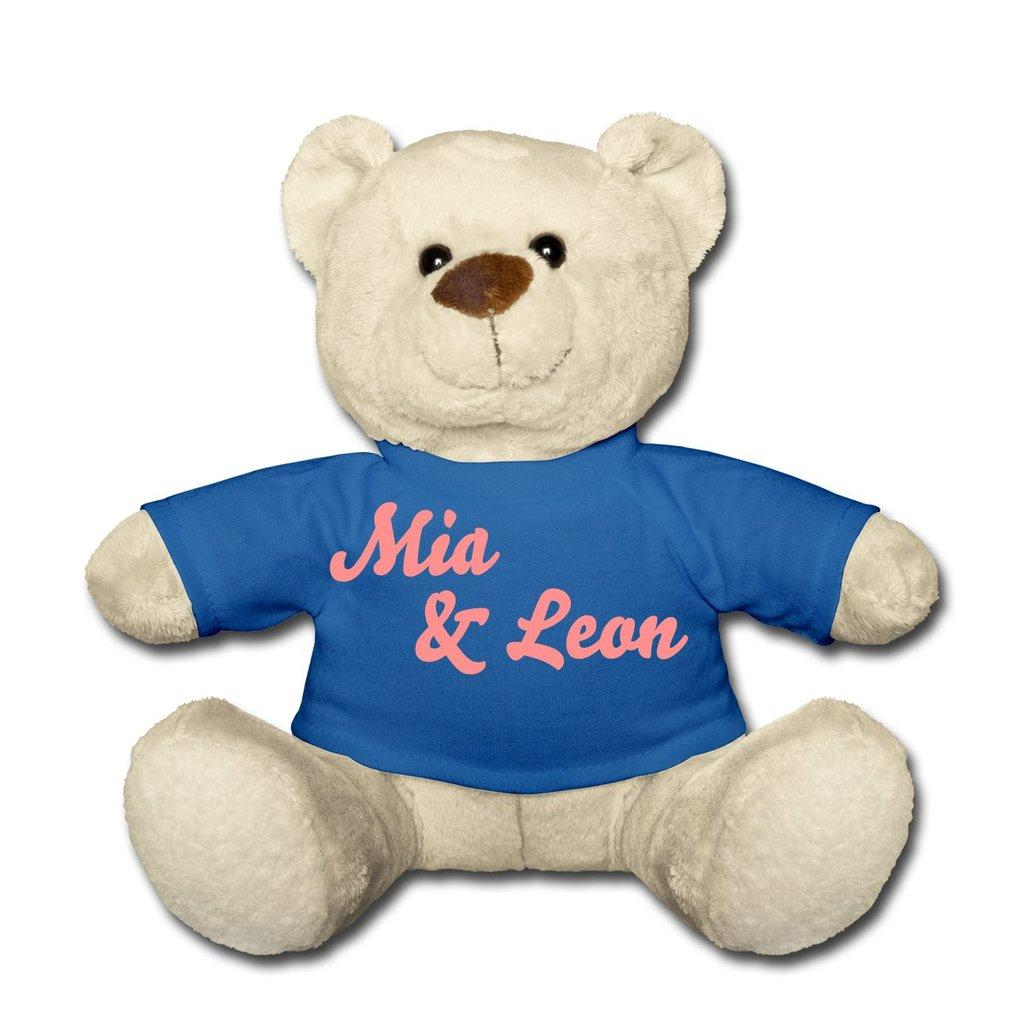What type of toy is present in the image? There is a white teddy in the image. What is the teddy wearing? The teddy is wearing a blue t-shirt. What color is the background of the image? The background of the image is white. What type of jar is visible on the teddy's head in the image? There is no jar present on the teddy's head in the image. 